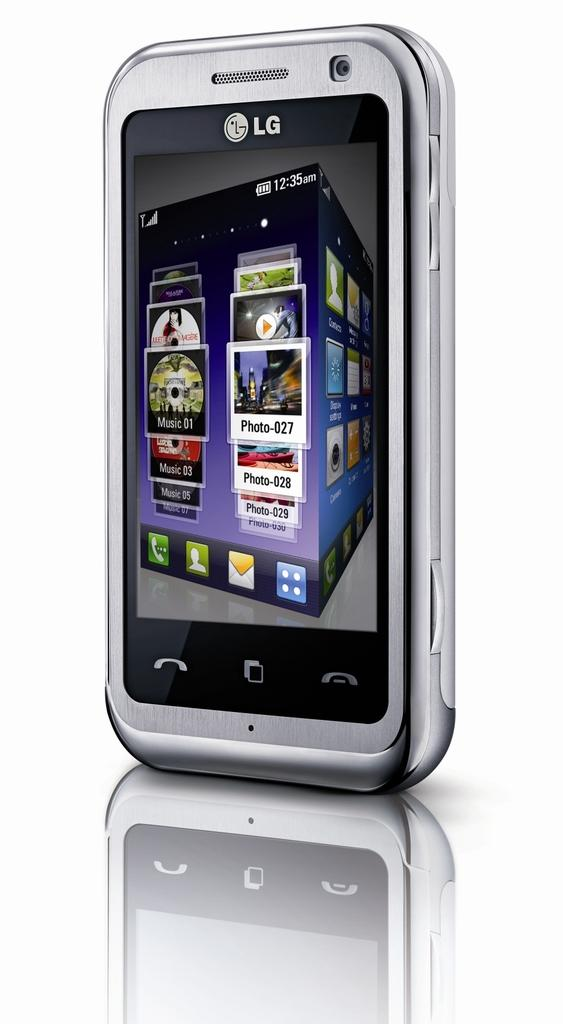<image>
Share a concise interpretation of the image provided. An LG phone's screen displays Music 01 and Photo-027. 